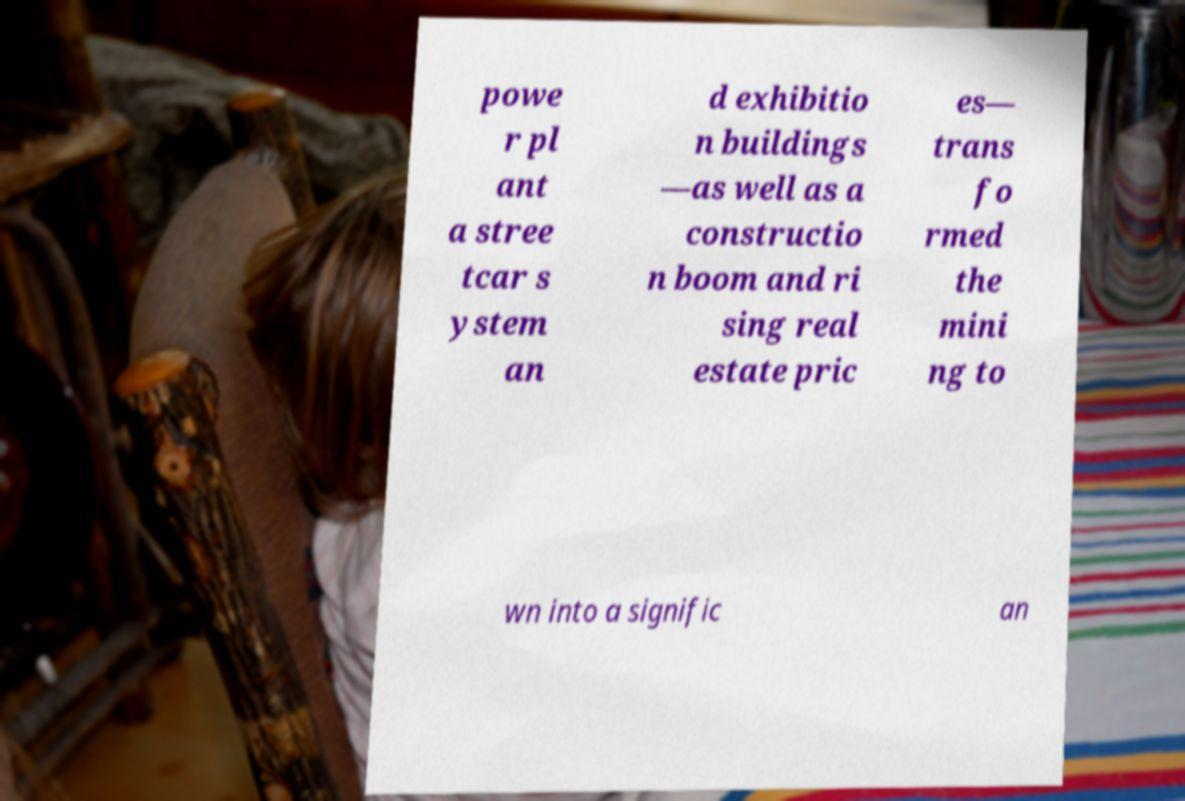I need the written content from this picture converted into text. Can you do that? powe r pl ant a stree tcar s ystem an d exhibitio n buildings —as well as a constructio n boom and ri sing real estate pric es— trans fo rmed the mini ng to wn into a signific an 